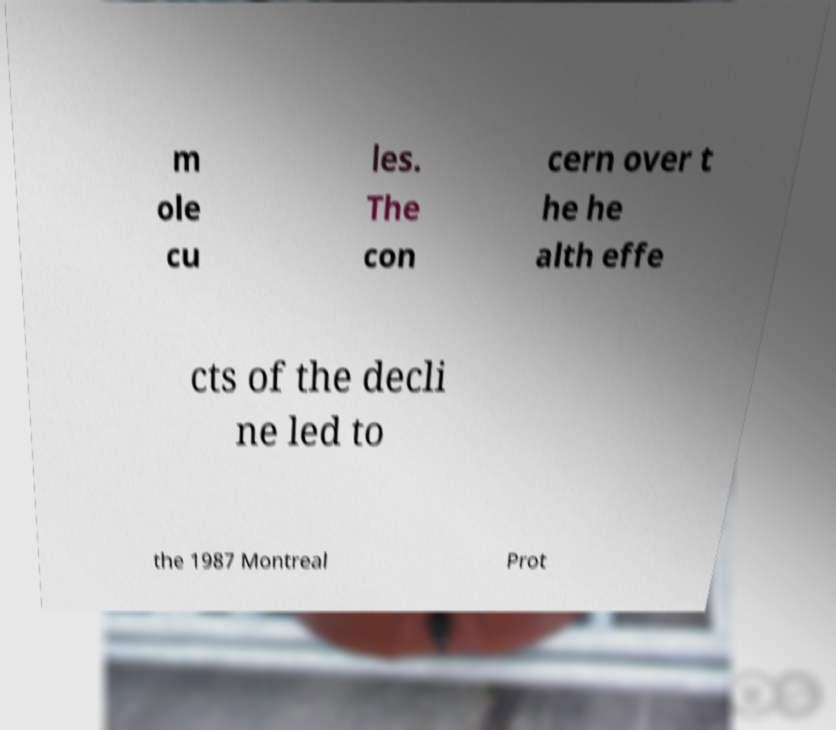I need the written content from this picture converted into text. Can you do that? m ole cu les. The con cern over t he he alth effe cts of the decli ne led to the 1987 Montreal Prot 